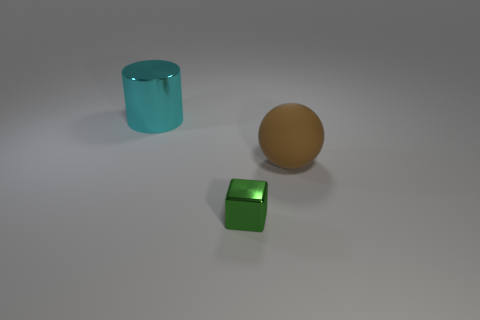Does the matte thing have the same shape as the green shiny object?
Make the answer very short. No. There is a large thing that is behind the brown rubber ball; what color is it?
Make the answer very short. Cyan. Do the matte ball and the cyan metal cylinder have the same size?
Offer a very short reply. Yes. What material is the big object that is to the left of the big thing that is in front of the cylinder?
Offer a terse response. Metal. What number of big metallic things are the same color as the big rubber sphere?
Your response must be concise. 0. Is there any other thing that has the same material as the brown object?
Your answer should be compact. No. Are there fewer large things to the left of the large cyan thing than small metallic cubes?
Provide a succinct answer. Yes. The shiny object behind the thing that is in front of the large matte thing is what color?
Offer a terse response. Cyan. How big is the shiny object that is to the right of the big object that is behind the big thing in front of the large cylinder?
Provide a short and direct response. Small. Are there fewer small green metallic things that are to the right of the large brown rubber object than large balls on the right side of the tiny metal thing?
Offer a terse response. Yes. 